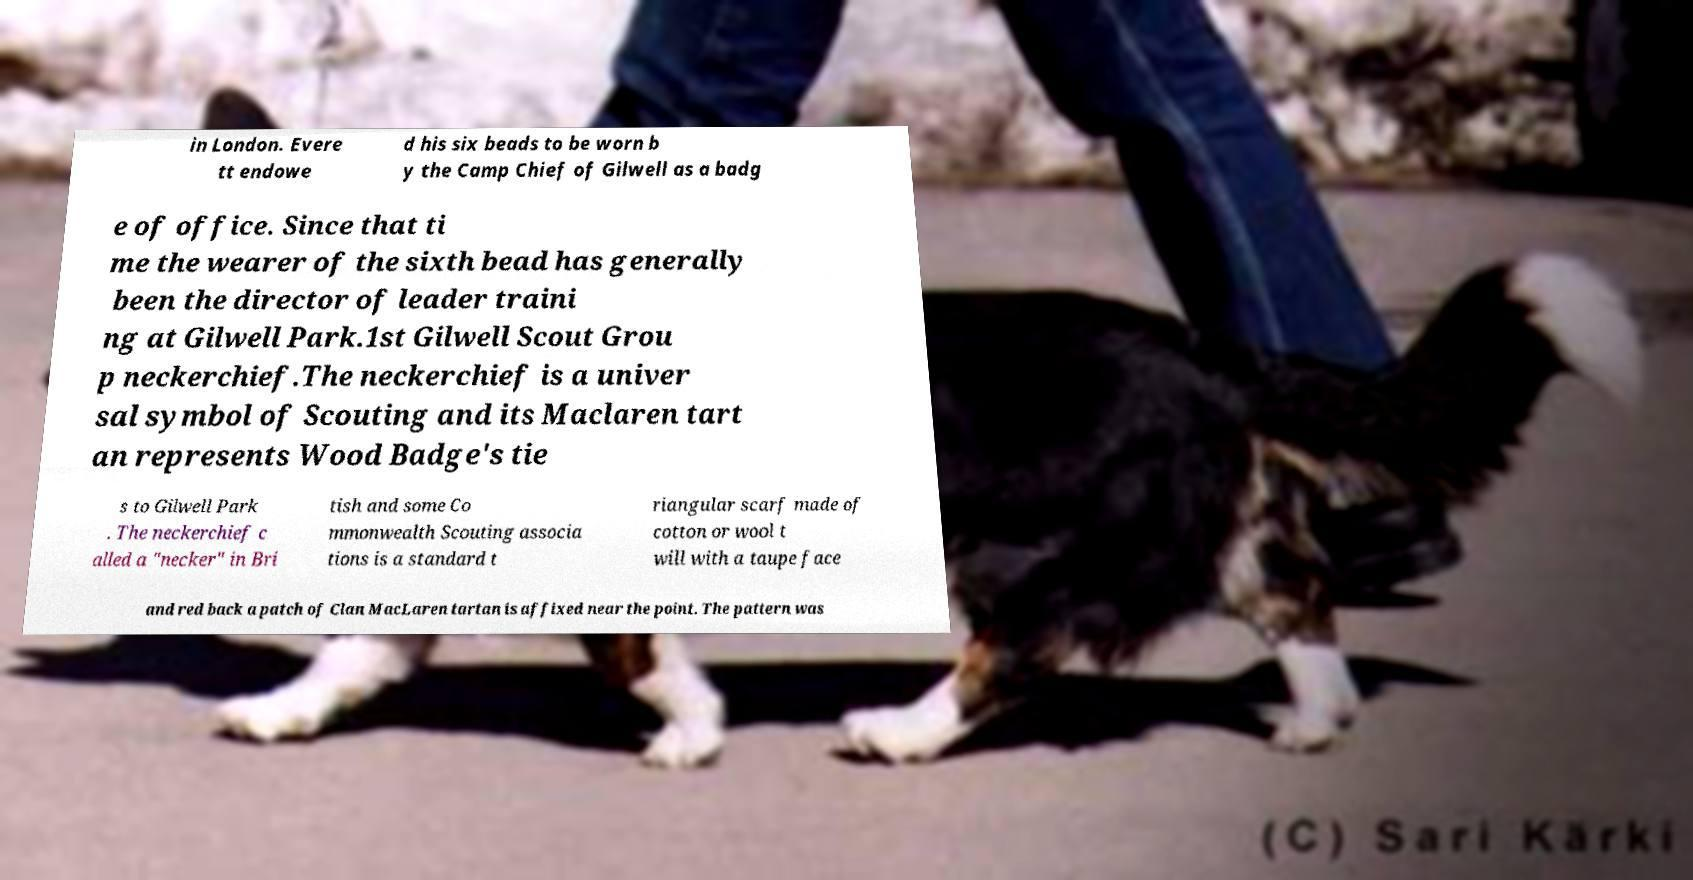There's text embedded in this image that I need extracted. Can you transcribe it verbatim? in London. Evere tt endowe d his six beads to be worn b y the Camp Chief of Gilwell as a badg e of office. Since that ti me the wearer of the sixth bead has generally been the director of leader traini ng at Gilwell Park.1st Gilwell Scout Grou p neckerchief.The neckerchief is a univer sal symbol of Scouting and its Maclaren tart an represents Wood Badge's tie s to Gilwell Park . The neckerchief c alled a "necker" in Bri tish and some Co mmonwealth Scouting associa tions is a standard t riangular scarf made of cotton or wool t will with a taupe face and red back a patch of Clan MacLaren tartan is affixed near the point. The pattern was 